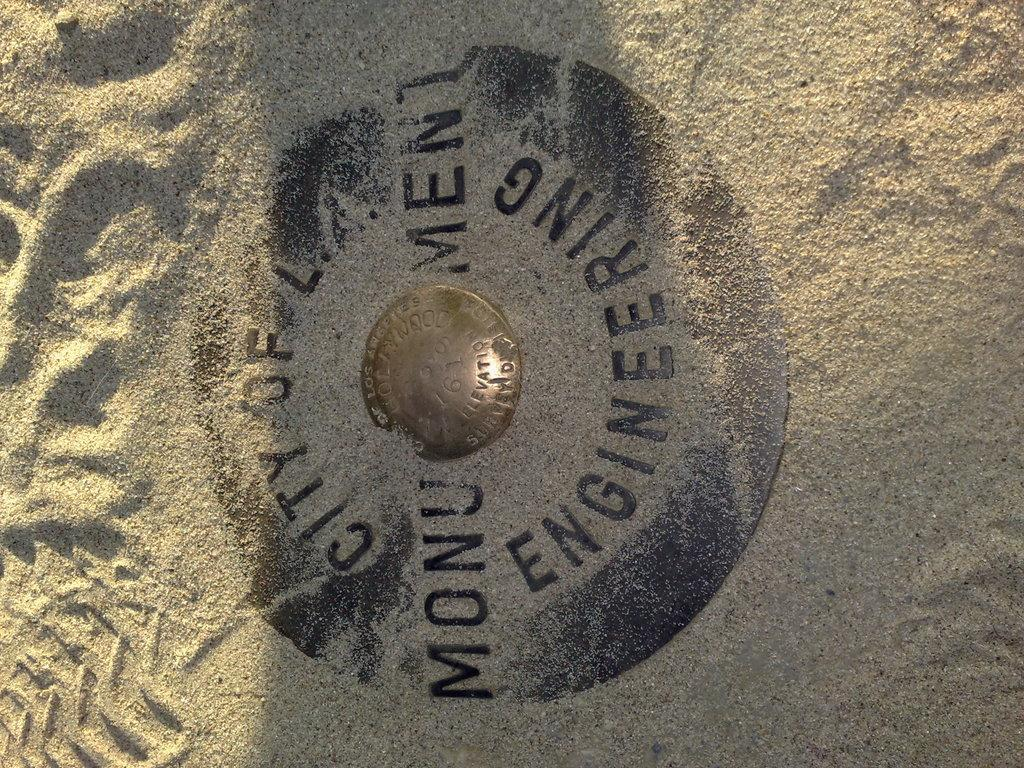Provide a one-sentence caption for the provided image. The sign covered in sand is about engineering monument. 